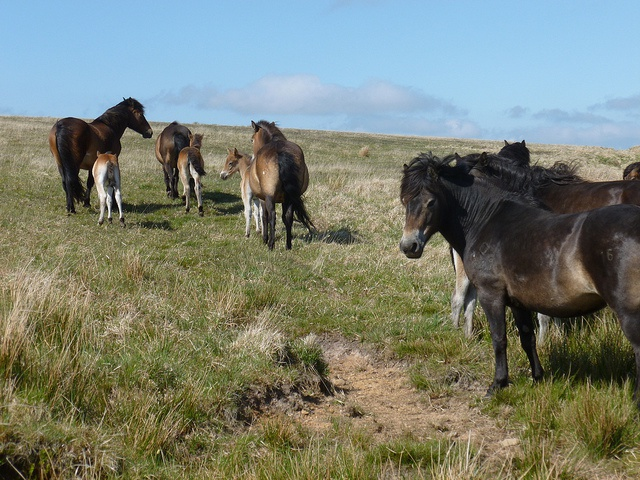Describe the objects in this image and their specific colors. I can see horse in lightblue, black, and gray tones, horse in lightblue, black, and gray tones, horse in lightblue, black, gray, and maroon tones, horse in lightblue, black, gray, and maroon tones, and horse in lightblue, black, and gray tones in this image. 